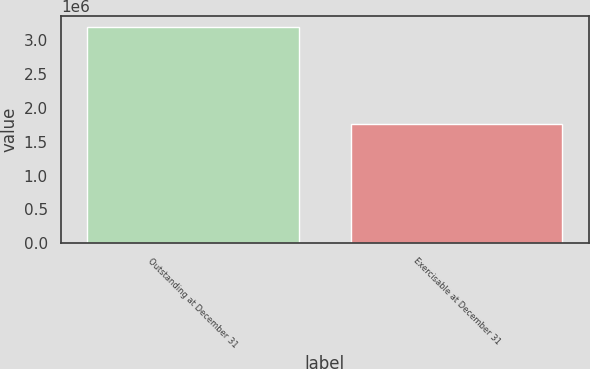<chart> <loc_0><loc_0><loc_500><loc_500><bar_chart><fcel>Outstanding at December 31<fcel>Exercisable at December 31<nl><fcel>3.19586e+06<fcel>1.76687e+06<nl></chart> 